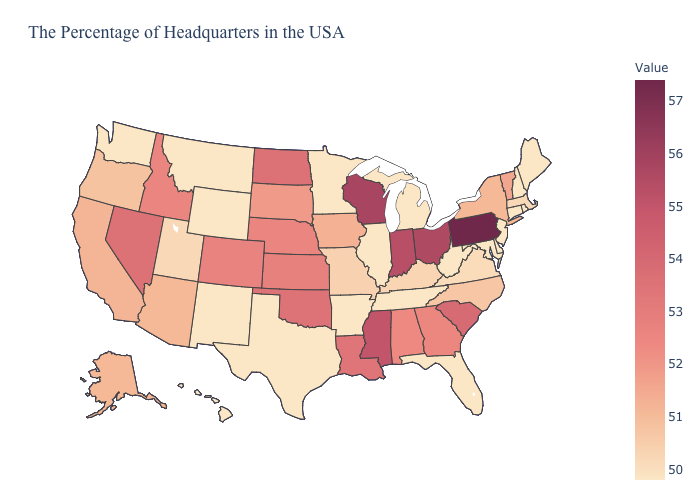Does the map have missing data?
Short answer required. No. Among the states that border Georgia , which have the highest value?
Keep it brief. South Carolina. Is the legend a continuous bar?
Write a very short answer. Yes. Which states hav the highest value in the Northeast?
Give a very brief answer. Pennsylvania. Which states hav the highest value in the West?
Keep it brief. Nevada. 